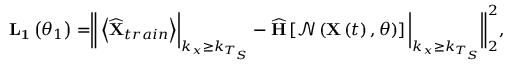Convert formula to latex. <formula><loc_0><loc_0><loc_500><loc_500>\begin{array} { r } { L _ { 1 } \left ( \theta _ { 1 } \right ) = \left \| \left < \widehat { X } _ { t r a i n } \right > \right | _ { k _ { x } \geq k _ { T _ { S } } } - \widehat { H } \left [ \mathcal { N } \left ( X \left ( t \right ) , \theta \right ) \right ] \left | _ { k _ { x } \geq k _ { T _ { S } } } \right \| _ { 2 } ^ { 2 } , } \end{array}</formula> 